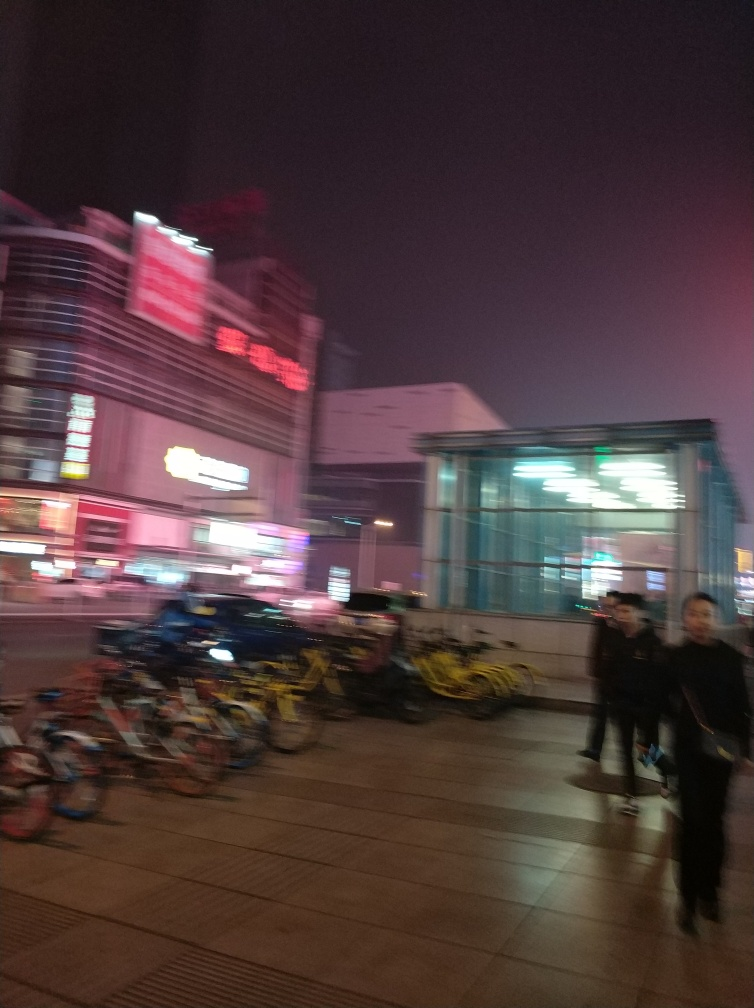Are the captured content blurry?
A. No
B. Yes
Answer with the option's letter from the given choices directly. B. The image is indeed blurry, which makes it challenging to discern fine details. The blurriness could be due to motion during the capture or a camera focus issue. 